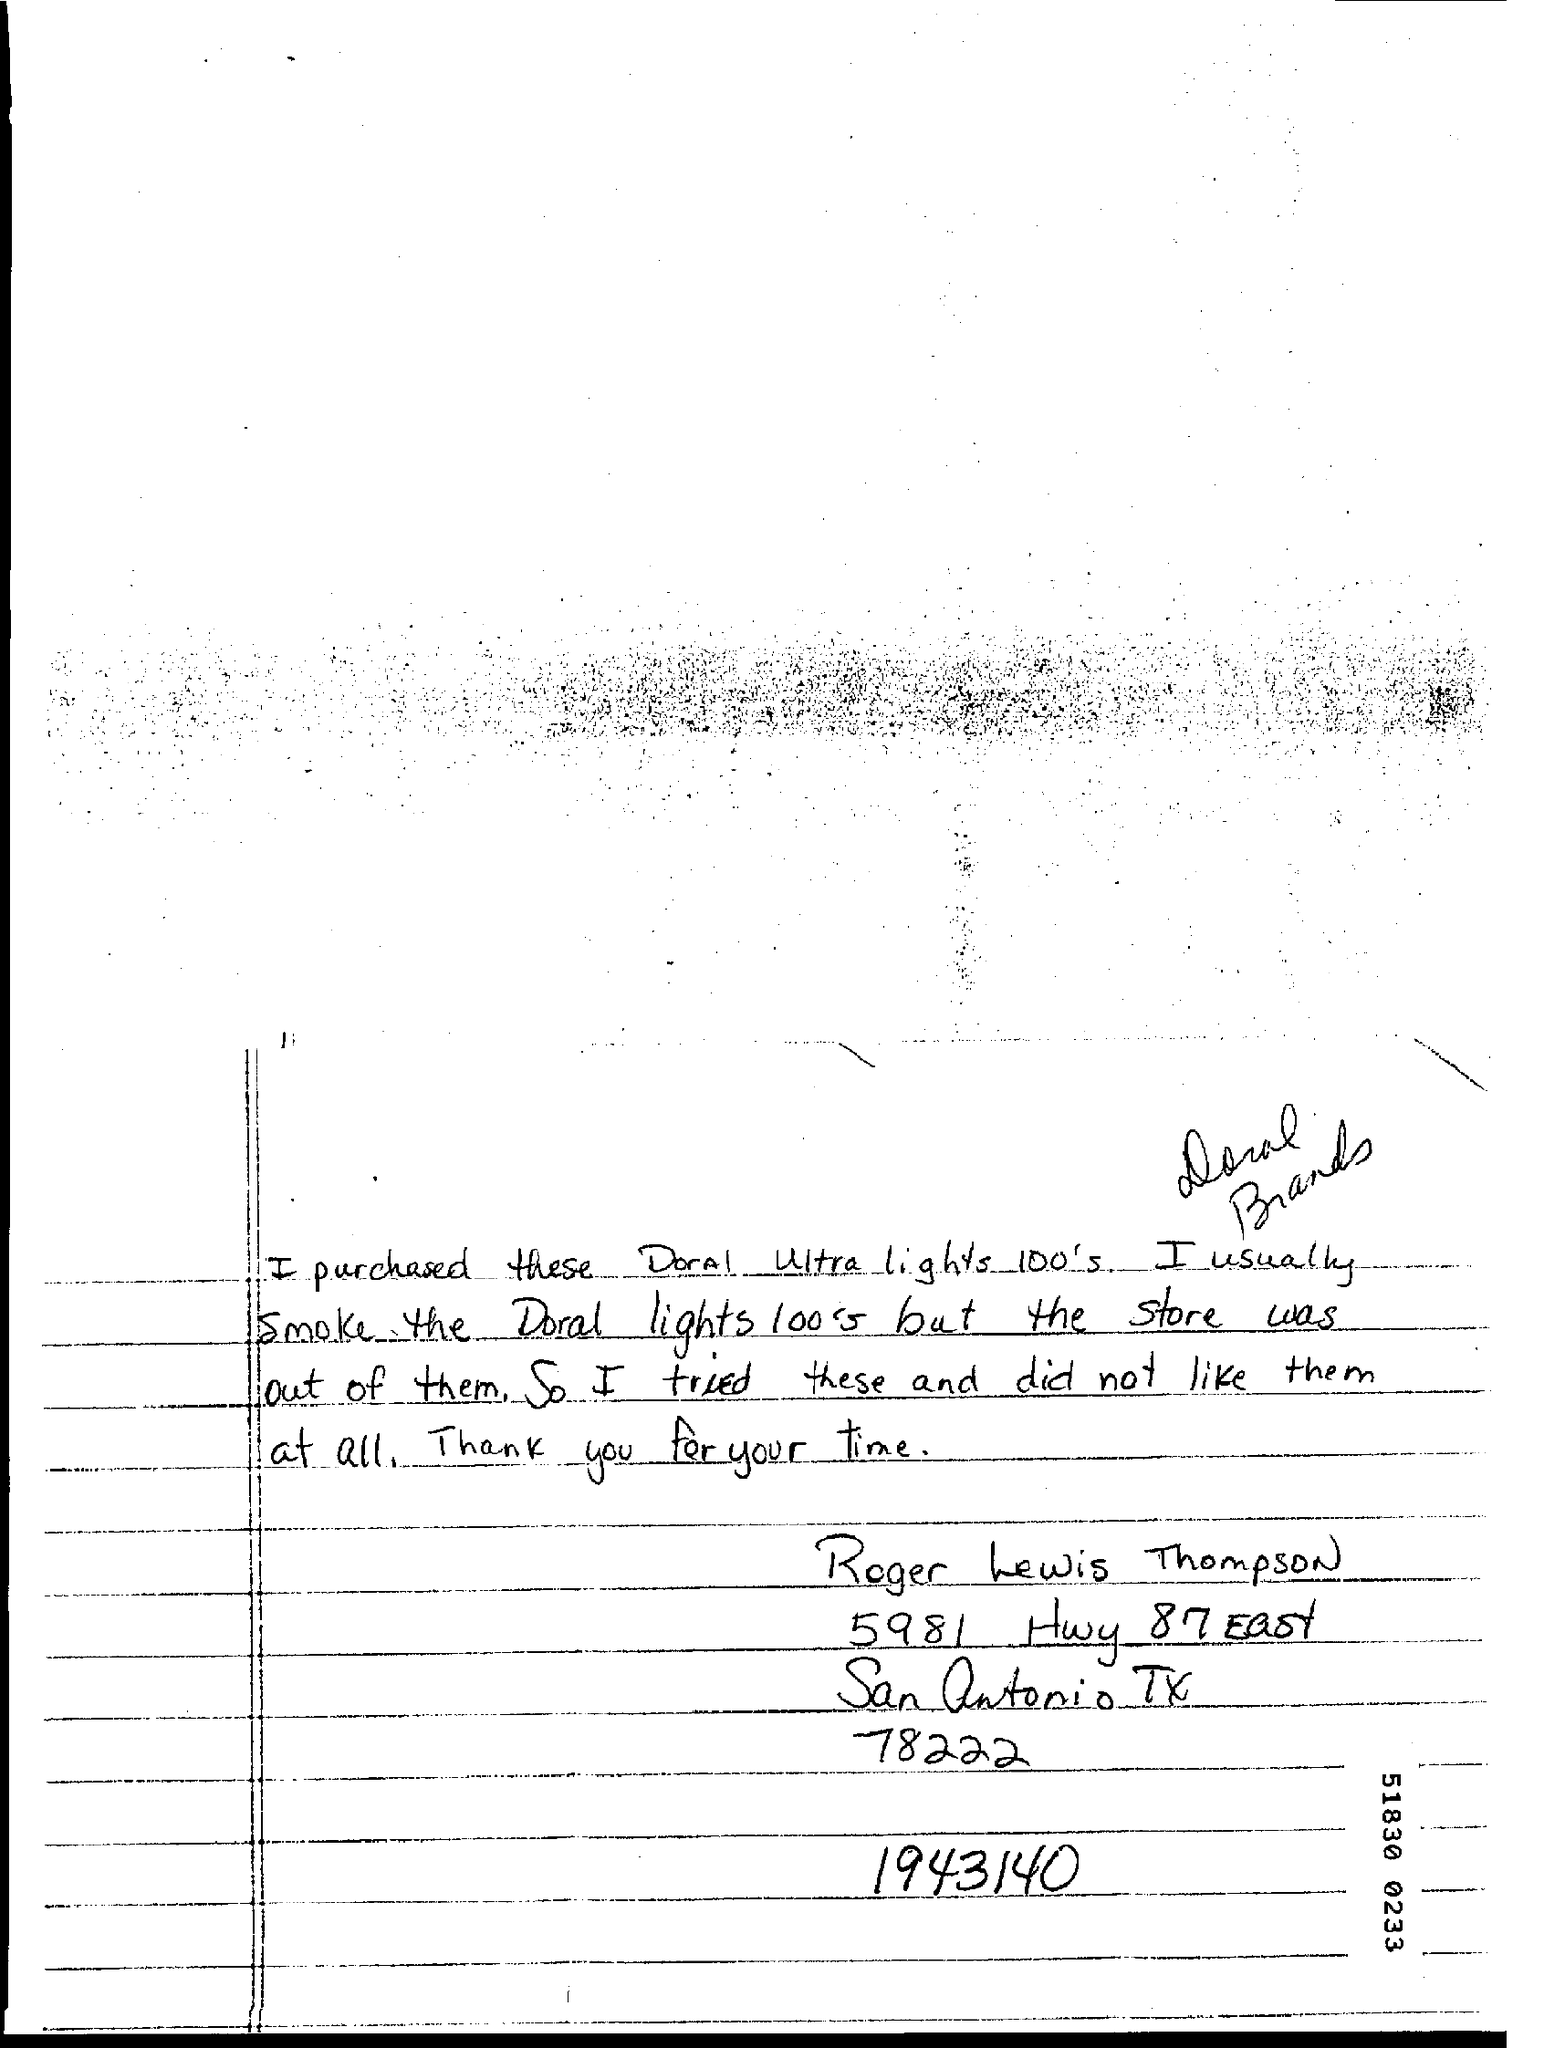Who has written the complaint?
Your answer should be compact. Roger Lewis Thompson. Which brand does Roger usually use?
Provide a short and direct response. Doral lights 100's. Which product did Roger try because his usual brand was not available?
Provide a short and direct response. Doral Ultra lights 100's. 